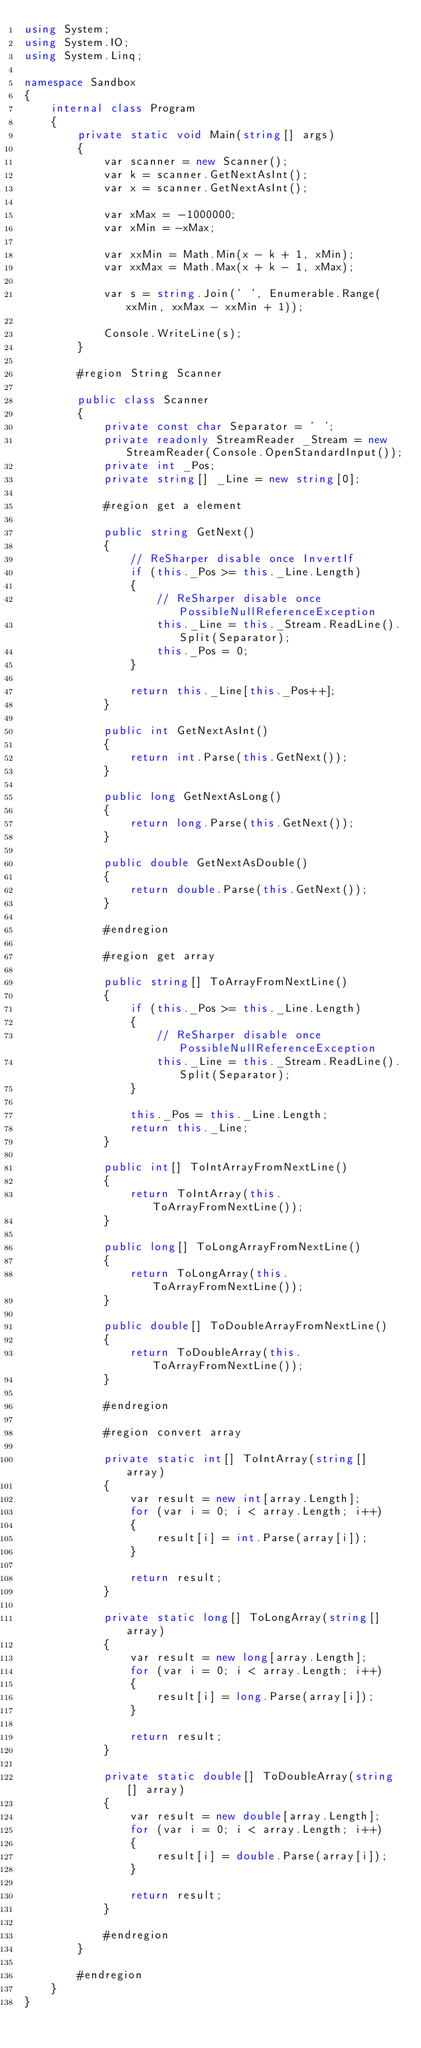Convert code to text. <code><loc_0><loc_0><loc_500><loc_500><_C#_>using System;
using System.IO;
using System.Linq;

namespace Sandbox
{
    internal class Program
    {
        private static void Main(string[] args)
        {
            var scanner = new Scanner();
            var k = scanner.GetNextAsInt();
            var x = scanner.GetNextAsInt();

            var xMax = -1000000;
            var xMin = -xMax;

            var xxMin = Math.Min(x - k + 1, xMin);
            var xxMax = Math.Max(x + k - 1, xMax);

            var s = string.Join(' ', Enumerable.Range(xxMin, xxMax - xxMin + 1));

            Console.WriteLine(s);
        }

        #region String Scanner

        public class Scanner
        {
            private const char Separator = ' ';
            private readonly StreamReader _Stream = new StreamReader(Console.OpenStandardInput());
            private int _Pos;
            private string[] _Line = new string[0];

            #region get a element

            public string GetNext()
            {
                // ReSharper disable once InvertIf
                if (this._Pos >= this._Line.Length)
                {
                    // ReSharper disable once PossibleNullReferenceException
                    this._Line = this._Stream.ReadLine().Split(Separator);
                    this._Pos = 0;
                }

                return this._Line[this._Pos++];
            }

            public int GetNextAsInt()
            {
                return int.Parse(this.GetNext());
            }

            public long GetNextAsLong()
            {
                return long.Parse(this.GetNext());
            }

            public double GetNextAsDouble()
            {
                return double.Parse(this.GetNext());
            }

            #endregion

            #region get array

            public string[] ToArrayFromNextLine()
            {
                if (this._Pos >= this._Line.Length)
                {
                    // ReSharper disable once PossibleNullReferenceException
                    this._Line = this._Stream.ReadLine().Split(Separator);
                }

                this._Pos = this._Line.Length;
                return this._Line;
            }

            public int[] ToIntArrayFromNextLine()
            {
                return ToIntArray(this.ToArrayFromNextLine());
            }

            public long[] ToLongArrayFromNextLine()
            {
                return ToLongArray(this.ToArrayFromNextLine());
            }

            public double[] ToDoubleArrayFromNextLine()
            {
                return ToDoubleArray(this.ToArrayFromNextLine());
            }

            #endregion

            #region convert array

            private static int[] ToIntArray(string[] array)
            {
                var result = new int[array.Length];
                for (var i = 0; i < array.Length; i++)
                {
                    result[i] = int.Parse(array[i]);
                }

                return result;
            }

            private static long[] ToLongArray(string[] array)
            {
                var result = new long[array.Length];
                for (var i = 0; i < array.Length; i++)
                {
                    result[i] = long.Parse(array[i]);
                }

                return result;
            }

            private static double[] ToDoubleArray(string[] array)
            {
                var result = new double[array.Length];
                for (var i = 0; i < array.Length; i++)
                {
                    result[i] = double.Parse(array[i]);
                }

                return result;
            }

            #endregion
        }

        #endregion
    }
}
</code> 